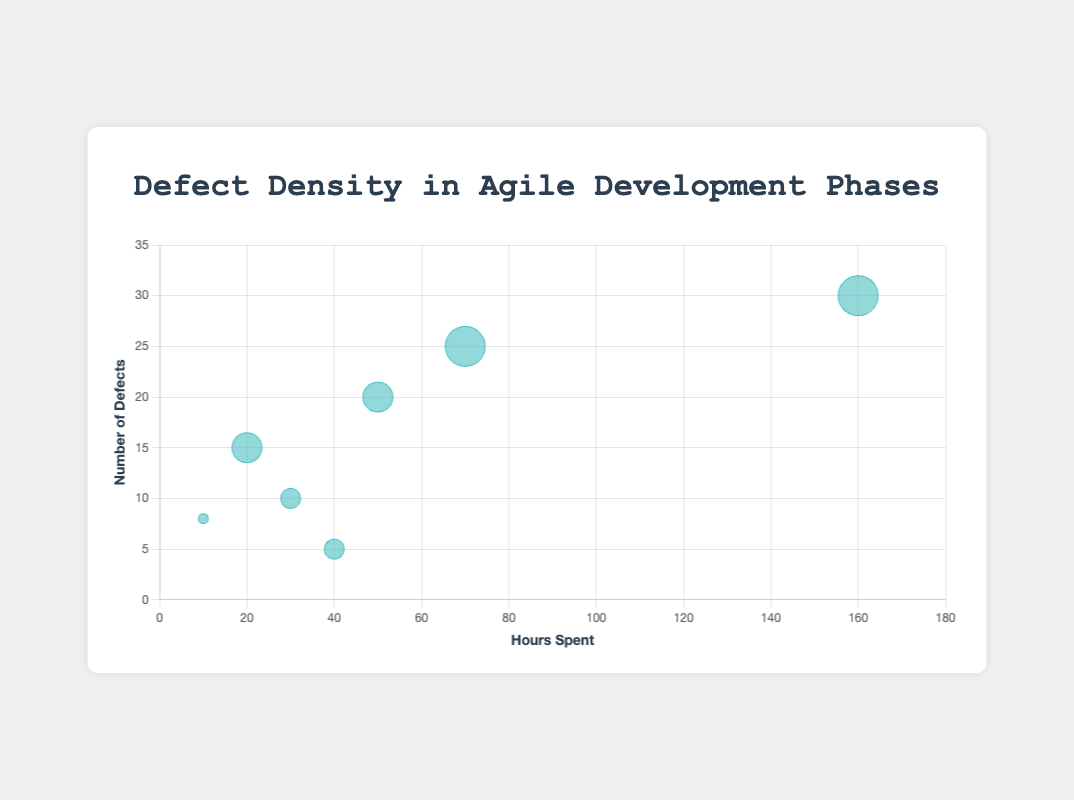What's the title of the chart? The title of the chart is prominently displayed at the top. It reads "Defect Density in Agile Development Phases."
Answer: Defect Density in Agile Development Phases What are the labels on the x and y axes? The x-axis label is "Hours Spent," and the y-axis label is "Number of Defects." These labels are shown near the beginning of each axis.
Answer: Hours Spent, Number of Defects Which phase had the highest number of defects? Looking at the chart, the bubble representing "Development" is the highest on the y-axis in terms of the number of defects.
Answer: Development How many hours were spent on "User Acceptance Testing"? The bubble for "User Acceptance Testing" is aligned with the x-axis at 70 hours.
Answer: 70 Which phases had a priority level of 4? We know that the size of the bubbles corresponds to the priority level. The larger bubbles have a priority level of 4. The phases are "Development" and "User Acceptance Testing".
Answer: Development, User Acceptance Testing What is the defect density for the "Code Review" phase (defects per hour)? For "Code Review," there are 15 defects over 20 hours. So, the defect density is 15/20.
Answer: 0.75 Which phase used the least amount of hours while having over 10 defects? Checking the x-axis for phases with over 10 defects, "Code Review" (15 defects at 20 hours) stands out as using the least hours and having over 10 defects.
Answer: Code Review Compare the hours spent in "Sprint Planning" vs. "Integration Testing." Which one used more time? The x-position for "Sprint Planning" is at 40 hours, while "Integration Testing" is at 50 hours. "Integration Testing" used more hours.
Answer: Integration Testing How does the number of defects in "Unit Testing" compare to "Deployment"? "Unit Testing" has 10 defects, and "Deployment" has 8 defects. So, "Unit Testing" has more defects.
Answer: Unit Testing What phase has the smallest bubble, and what does it indicate about its priority? The smallest bubble represents "Deployment," indicating it has the lowest priority level (1).
Answer: Deployment 